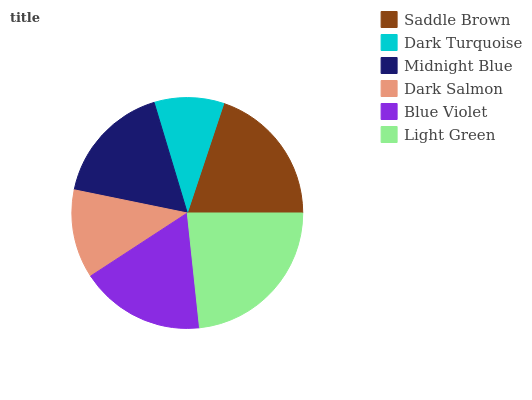Is Dark Turquoise the minimum?
Answer yes or no. Yes. Is Light Green the maximum?
Answer yes or no. Yes. Is Midnight Blue the minimum?
Answer yes or no. No. Is Midnight Blue the maximum?
Answer yes or no. No. Is Midnight Blue greater than Dark Turquoise?
Answer yes or no. Yes. Is Dark Turquoise less than Midnight Blue?
Answer yes or no. Yes. Is Dark Turquoise greater than Midnight Blue?
Answer yes or no. No. Is Midnight Blue less than Dark Turquoise?
Answer yes or no. No. Is Blue Violet the high median?
Answer yes or no. Yes. Is Midnight Blue the low median?
Answer yes or no. Yes. Is Midnight Blue the high median?
Answer yes or no. No. Is Light Green the low median?
Answer yes or no. No. 